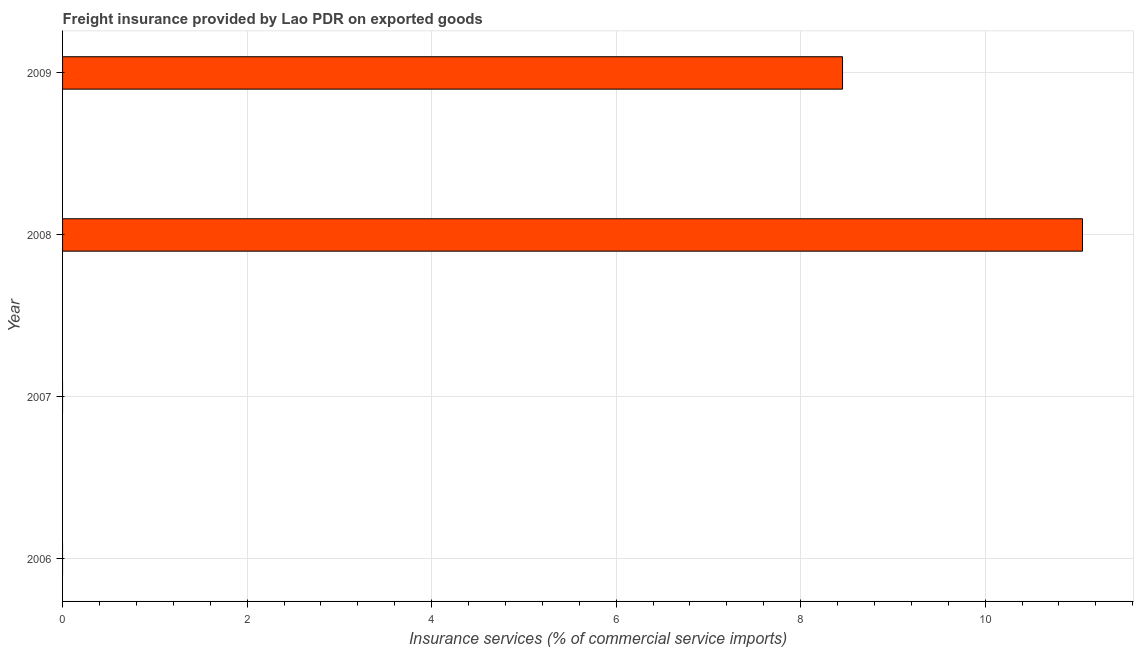Does the graph contain grids?
Make the answer very short. Yes. What is the title of the graph?
Your response must be concise. Freight insurance provided by Lao PDR on exported goods . What is the label or title of the X-axis?
Provide a short and direct response. Insurance services (% of commercial service imports). What is the freight insurance in 2009?
Your answer should be compact. 8.45. Across all years, what is the maximum freight insurance?
Offer a very short reply. 11.05. Across all years, what is the minimum freight insurance?
Your answer should be compact. 0. In which year was the freight insurance maximum?
Offer a terse response. 2008. What is the sum of the freight insurance?
Give a very brief answer. 19.51. What is the difference between the freight insurance in 2008 and 2009?
Ensure brevity in your answer.  2.6. What is the average freight insurance per year?
Provide a succinct answer. 4.88. What is the median freight insurance?
Give a very brief answer. 4.23. In how many years, is the freight insurance greater than 11.2 %?
Provide a succinct answer. 0. What is the ratio of the freight insurance in 2008 to that in 2009?
Ensure brevity in your answer.  1.31. Is the freight insurance in 2008 less than that in 2009?
Provide a succinct answer. No. Is the difference between the freight insurance in 2008 and 2009 greater than the difference between any two years?
Provide a short and direct response. No. What is the difference between the highest and the lowest freight insurance?
Keep it short and to the point. 11.05. What is the difference between two consecutive major ticks on the X-axis?
Your answer should be very brief. 2. Are the values on the major ticks of X-axis written in scientific E-notation?
Offer a terse response. No. What is the Insurance services (% of commercial service imports) in 2007?
Provide a short and direct response. 0. What is the Insurance services (% of commercial service imports) in 2008?
Give a very brief answer. 11.05. What is the Insurance services (% of commercial service imports) of 2009?
Offer a very short reply. 8.45. What is the difference between the Insurance services (% of commercial service imports) in 2008 and 2009?
Keep it short and to the point. 2.6. What is the ratio of the Insurance services (% of commercial service imports) in 2008 to that in 2009?
Your response must be concise. 1.31. 